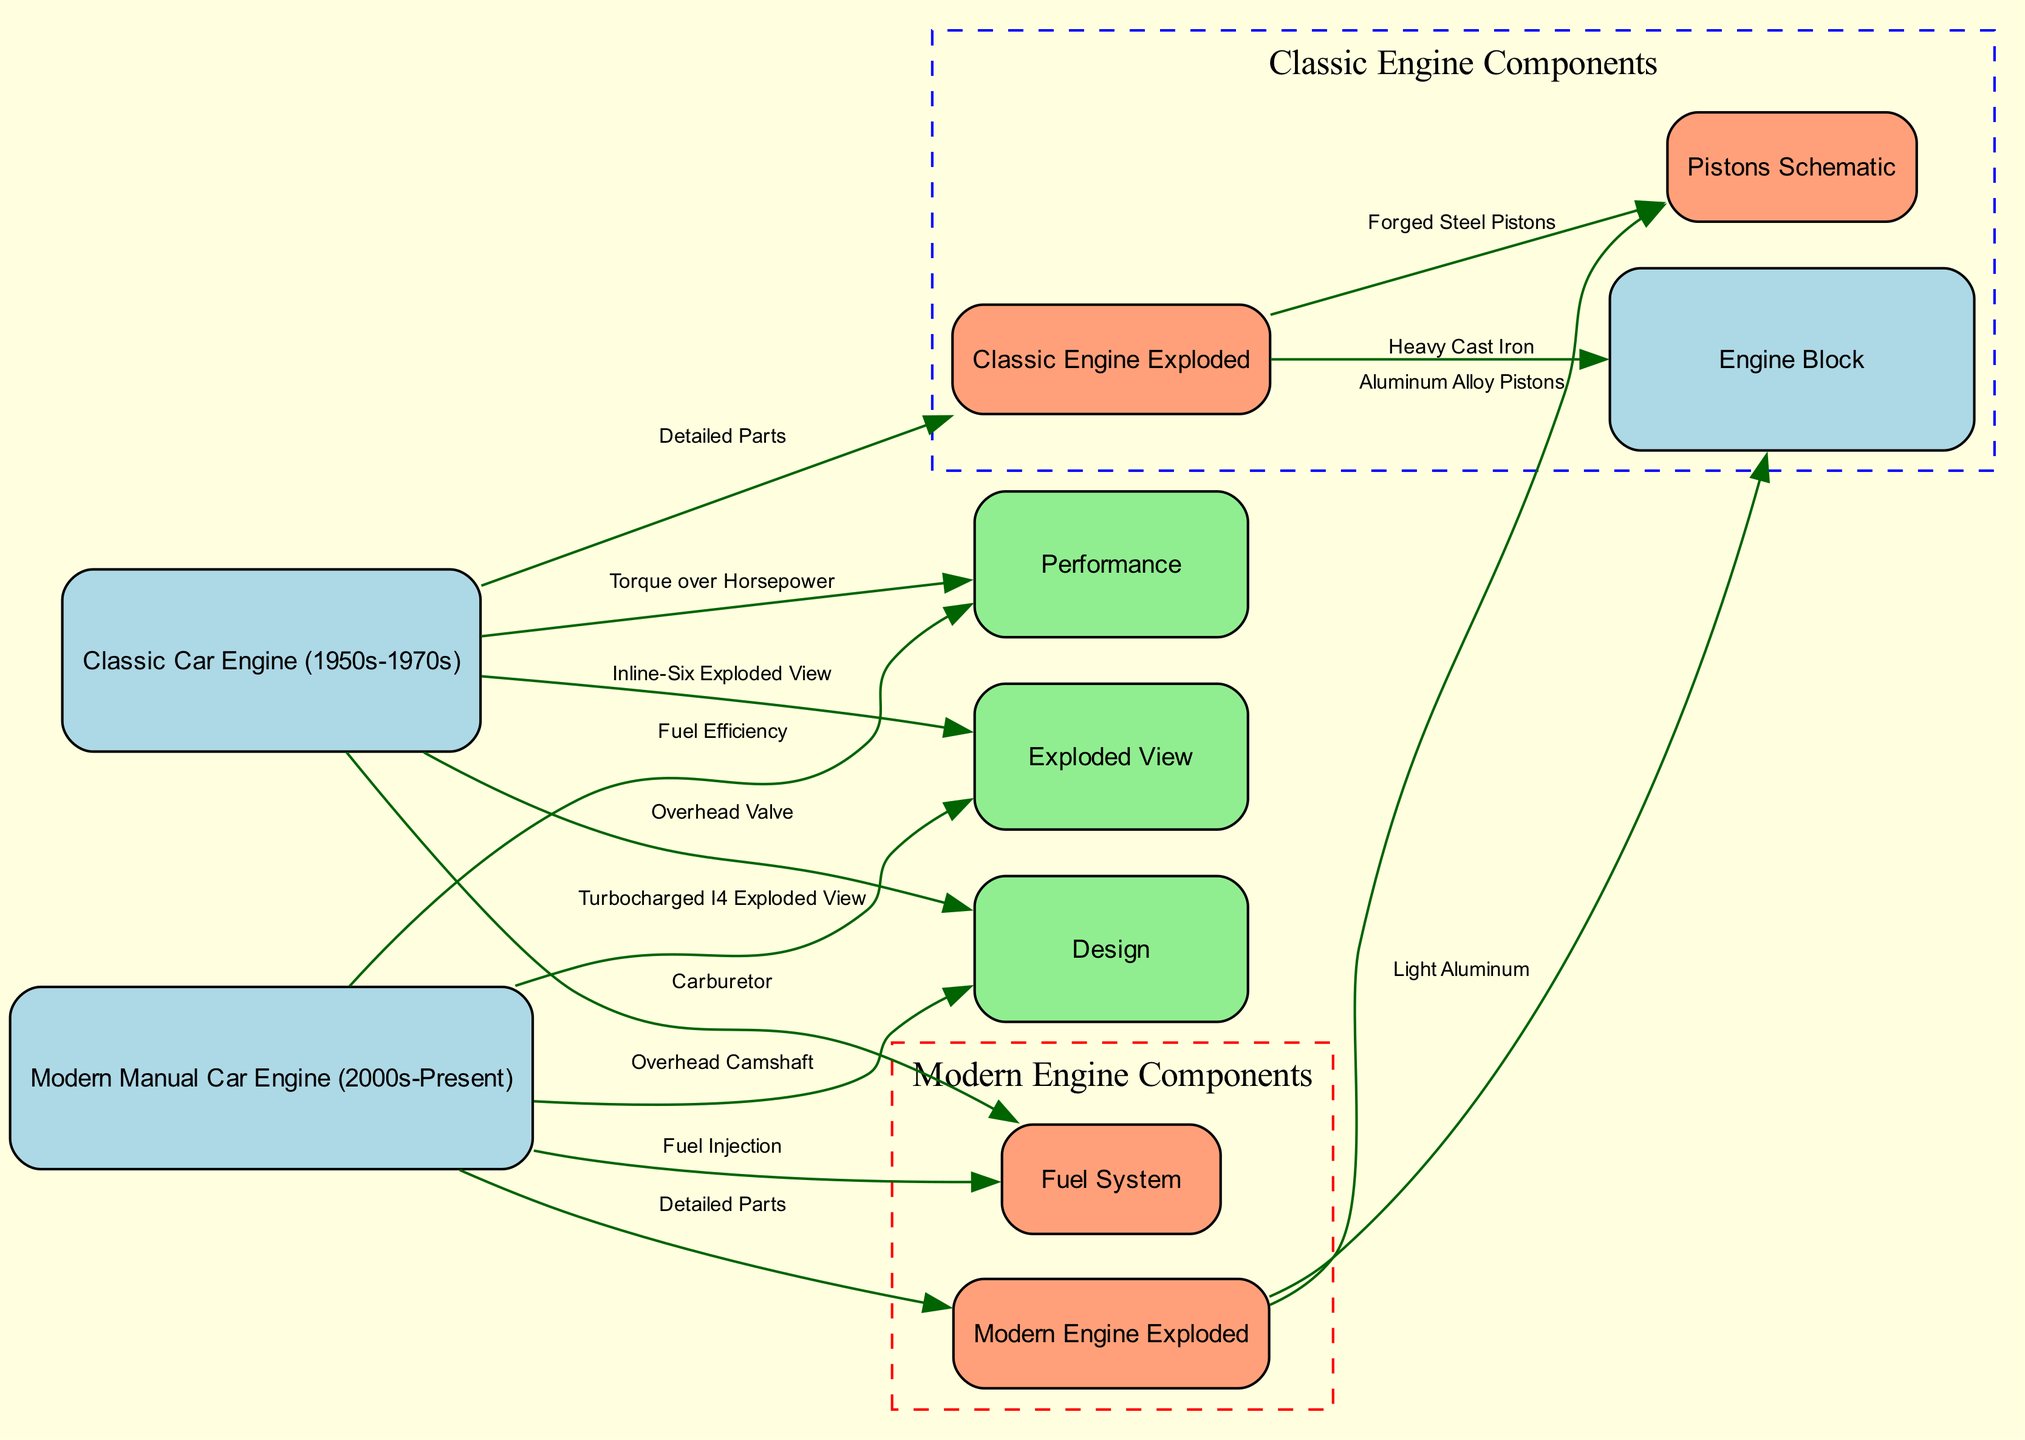What type of fuel system does the classic car engine use? The diagram indicates that the classic car engine is connected to the "Fuel System" node with the label "Carburetor." This information shows that the classic engine is using a carburetor for fuel delivery.
Answer: Carburetor What is the design feature of the modern manual car engine? By examining the edge connecting "Modern Manual Car Engine" to "Design," labeled "Overhead Camshaft," we can tell that the design feature focused on in this case is the overhead camshaft characteristic of modern engines.
Answer: Overhead Camshaft How does the performance of classic engines compare to modern manual engines? The edges leading from both engine types to the "Performance" node indicate characteristics defining their performance: "Torque over Horsepower" for classic engines and "Fuel Efficiency" for modern manual engines. This shows a contrast in performance focus between the two engine types.
Answer: Torque over Horsepower; Fuel Efficiency Which engine type has a lighter engine block? Looking closely at the edges from the "Modern Engine Exploded" node leading to "Engine Block," it is labeled "Light Aluminum," while for the classic engine the corresponding label is "Heavy Cast Iron." Hence, the modern engine has a lighter engine block made of aluminum.
Answer: Light Aluminum What component is used in modern manual car pistons? The "Modern Engine Exploded" node connects to "Pistons Schematic" with the label "Aluminum Alloy Pistons." This clearly indicates the material used in the pistons of modern manual cars, which are aluminum alloys.
Answer: Aluminum Alloy Pistons How many edges connect the classic engine to other nodes? By counting the edges stemming from the "Classic Car Engine" node, we find it connects to four other nodes. This includes performance, design, exploded view, and fuel system. Hence, the number of edges is four.
Answer: 4 What does the exploded view of the classic engine include? The edge labeled "Detailed Parts" connects the "Classic Engine Exploded" to the "Engine Block" and "Pistons Schematic". It indicates that the exploded view showcases these components within the classic engine diagram specifically.
Answer: Heavy Cast Iron, Forged Steel Pistons What visual representation illustrates the modern multi-part engine? The "Modern Engine Exploded" node illustrates components such as the engine block and the fuel system in detail, showing a depth of modern engine design in contrast to the classic simpler engine. This multi-part representation demonstrates modern engineering nuances.
Answer: Detailed Parts 